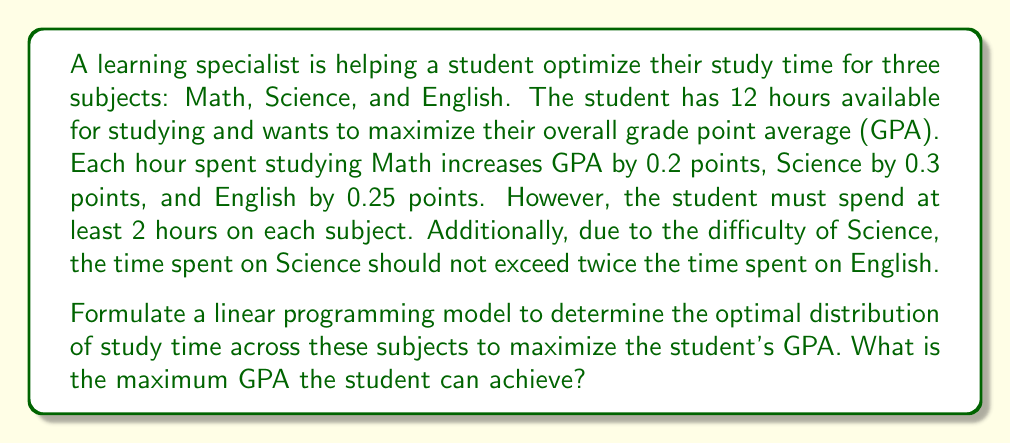Provide a solution to this math problem. Let's approach this step-by-step:

1) Define variables:
   Let $x$ = hours spent on Math
   Let $y$ = hours spent on Science
   Let $z$ = hours spent on English

2) Objective function:
   Maximize GPA = $0.2x + 0.3y + 0.25z$

3) Constraints:
   a) Total time constraint: $x + y + z \leq 12$
   b) Minimum time for each subject: $x \geq 2$, $y \geq 2$, $z \geq 2$
   c) Science time constraint: $y \leq 2z$
   d) Non-negativity: $x, y, z \geq 0$

4) Linear Programming Model:
   Maximize $0.2x + 0.3y + 0.25z$
   Subject to:
   $x + y + z \leq 12$
   $x \geq 2$
   $y \geq 2$
   $z \geq 2$
   $y \leq 2z$
   $x, y, z \geq 0$

5) Solving the model:
   We can solve this using the simplex method or linear programming software. The optimal solution is:
   $x = 2$ (Math)
   $y = 6$ (Science)
   $z = 4$ (English)

6) Calculating maximum GPA:
   Maximum GPA = $0.2(2) + 0.3(6) + 0.25(4)$
                = $0.4 + 1.8 + 1.0$
                = $3.2$

Therefore, the maximum GPA the student can achieve is 3.2.
Answer: 3.2 